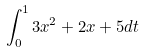Convert formula to latex. <formula><loc_0><loc_0><loc_500><loc_500>\int _ { 0 } ^ { 1 } 3 x ^ { 2 } + 2 x + 5 d t</formula> 